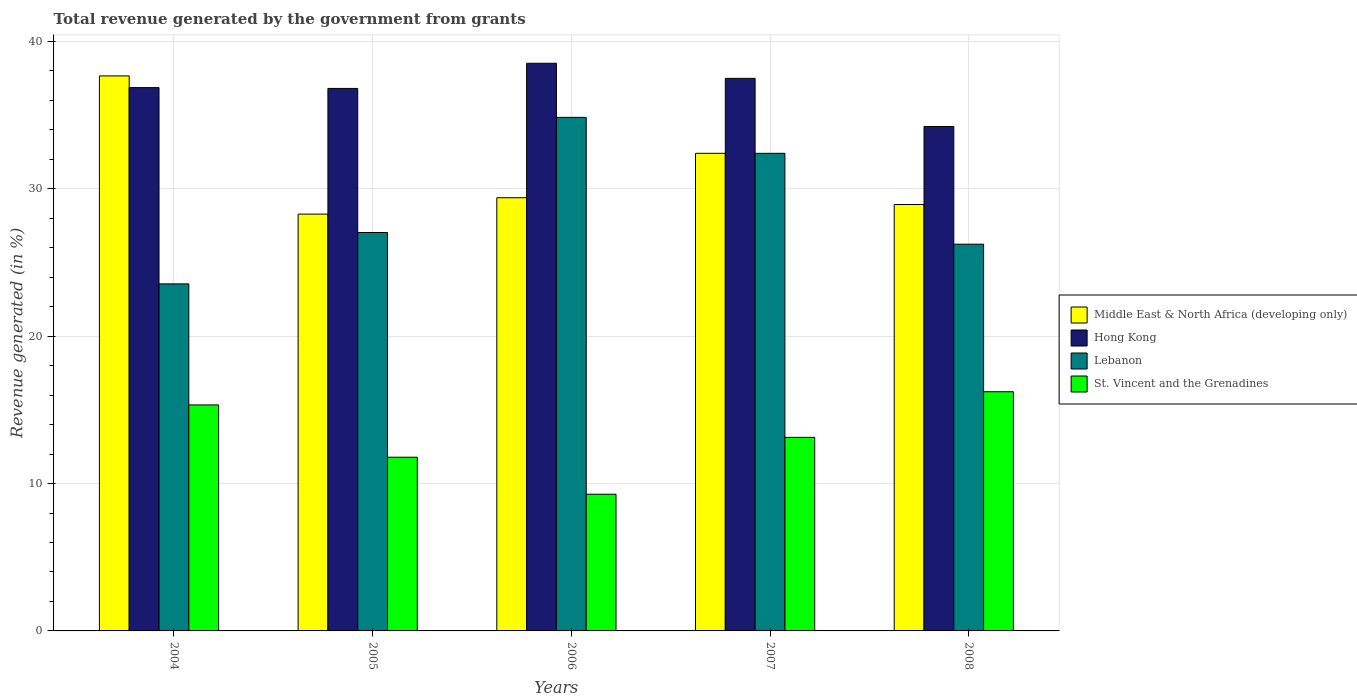Are the number of bars on each tick of the X-axis equal?
Provide a succinct answer. Yes. In how many cases, is the number of bars for a given year not equal to the number of legend labels?
Provide a short and direct response. 0. What is the total revenue generated in Middle East & North Africa (developing only) in 2006?
Keep it short and to the point. 29.4. Across all years, what is the maximum total revenue generated in Lebanon?
Ensure brevity in your answer.  34.85. Across all years, what is the minimum total revenue generated in Middle East & North Africa (developing only)?
Your answer should be compact. 28.29. In which year was the total revenue generated in St. Vincent and the Grenadines maximum?
Offer a terse response. 2008. What is the total total revenue generated in Middle East & North Africa (developing only) in the graph?
Offer a very short reply. 156.7. What is the difference between the total revenue generated in Hong Kong in 2004 and that in 2006?
Your response must be concise. -1.65. What is the difference between the total revenue generated in Hong Kong in 2005 and the total revenue generated in St. Vincent and the Grenadines in 2006?
Your answer should be compact. 27.54. What is the average total revenue generated in St. Vincent and the Grenadines per year?
Your answer should be very brief. 13.15. In the year 2004, what is the difference between the total revenue generated in St. Vincent and the Grenadines and total revenue generated in Lebanon?
Offer a terse response. -8.21. In how many years, is the total revenue generated in Hong Kong greater than 14 %?
Keep it short and to the point. 5. What is the ratio of the total revenue generated in Middle East & North Africa (developing only) in 2004 to that in 2006?
Keep it short and to the point. 1.28. Is the difference between the total revenue generated in St. Vincent and the Grenadines in 2006 and 2008 greater than the difference between the total revenue generated in Lebanon in 2006 and 2008?
Make the answer very short. No. What is the difference between the highest and the second highest total revenue generated in Middle East & North Africa (developing only)?
Your response must be concise. 5.25. What is the difference between the highest and the lowest total revenue generated in Middle East & North Africa (developing only)?
Ensure brevity in your answer.  9.38. In how many years, is the total revenue generated in Middle East & North Africa (developing only) greater than the average total revenue generated in Middle East & North Africa (developing only) taken over all years?
Give a very brief answer. 2. Is the sum of the total revenue generated in Hong Kong in 2004 and 2007 greater than the maximum total revenue generated in Middle East & North Africa (developing only) across all years?
Your answer should be very brief. Yes. What does the 2nd bar from the left in 2004 represents?
Ensure brevity in your answer.  Hong Kong. What does the 3rd bar from the right in 2005 represents?
Provide a short and direct response. Hong Kong. How many bars are there?
Your answer should be compact. 20. Are all the bars in the graph horizontal?
Make the answer very short. No. What is the difference between two consecutive major ticks on the Y-axis?
Offer a terse response. 10. Does the graph contain any zero values?
Ensure brevity in your answer.  No. Does the graph contain grids?
Give a very brief answer. Yes. How many legend labels are there?
Give a very brief answer. 4. How are the legend labels stacked?
Provide a succinct answer. Vertical. What is the title of the graph?
Ensure brevity in your answer.  Total revenue generated by the government from grants. Does "Greenland" appear as one of the legend labels in the graph?
Make the answer very short. No. What is the label or title of the Y-axis?
Make the answer very short. Revenue generated (in %). What is the Revenue generated (in %) of Middle East & North Africa (developing only) in 2004?
Keep it short and to the point. 37.67. What is the Revenue generated (in %) in Hong Kong in 2004?
Provide a short and direct response. 36.87. What is the Revenue generated (in %) in Lebanon in 2004?
Give a very brief answer. 23.55. What is the Revenue generated (in %) of St. Vincent and the Grenadines in 2004?
Provide a short and direct response. 15.34. What is the Revenue generated (in %) in Middle East & North Africa (developing only) in 2005?
Provide a short and direct response. 28.29. What is the Revenue generated (in %) of Hong Kong in 2005?
Make the answer very short. 36.82. What is the Revenue generated (in %) of Lebanon in 2005?
Provide a succinct answer. 27.04. What is the Revenue generated (in %) of St. Vincent and the Grenadines in 2005?
Provide a succinct answer. 11.79. What is the Revenue generated (in %) in Middle East & North Africa (developing only) in 2006?
Provide a succinct answer. 29.4. What is the Revenue generated (in %) in Hong Kong in 2006?
Your answer should be compact. 38.52. What is the Revenue generated (in %) in Lebanon in 2006?
Make the answer very short. 34.85. What is the Revenue generated (in %) in St. Vincent and the Grenadines in 2006?
Your response must be concise. 9.28. What is the Revenue generated (in %) of Middle East & North Africa (developing only) in 2007?
Offer a terse response. 32.41. What is the Revenue generated (in %) in Hong Kong in 2007?
Your answer should be compact. 37.5. What is the Revenue generated (in %) in Lebanon in 2007?
Provide a short and direct response. 32.41. What is the Revenue generated (in %) of St. Vincent and the Grenadines in 2007?
Provide a short and direct response. 13.14. What is the Revenue generated (in %) of Middle East & North Africa (developing only) in 2008?
Ensure brevity in your answer.  28.94. What is the Revenue generated (in %) of Hong Kong in 2008?
Make the answer very short. 34.23. What is the Revenue generated (in %) of Lebanon in 2008?
Provide a succinct answer. 26.24. What is the Revenue generated (in %) of St. Vincent and the Grenadines in 2008?
Give a very brief answer. 16.23. Across all years, what is the maximum Revenue generated (in %) in Middle East & North Africa (developing only)?
Provide a succinct answer. 37.67. Across all years, what is the maximum Revenue generated (in %) in Hong Kong?
Make the answer very short. 38.52. Across all years, what is the maximum Revenue generated (in %) in Lebanon?
Ensure brevity in your answer.  34.85. Across all years, what is the maximum Revenue generated (in %) in St. Vincent and the Grenadines?
Provide a succinct answer. 16.23. Across all years, what is the minimum Revenue generated (in %) of Middle East & North Africa (developing only)?
Provide a short and direct response. 28.29. Across all years, what is the minimum Revenue generated (in %) in Hong Kong?
Keep it short and to the point. 34.23. Across all years, what is the minimum Revenue generated (in %) in Lebanon?
Offer a terse response. 23.55. Across all years, what is the minimum Revenue generated (in %) in St. Vincent and the Grenadines?
Your response must be concise. 9.28. What is the total Revenue generated (in %) of Middle East & North Africa (developing only) in the graph?
Provide a short and direct response. 156.7. What is the total Revenue generated (in %) in Hong Kong in the graph?
Offer a terse response. 183.95. What is the total Revenue generated (in %) in Lebanon in the graph?
Offer a very short reply. 144.1. What is the total Revenue generated (in %) in St. Vincent and the Grenadines in the graph?
Ensure brevity in your answer.  65.77. What is the difference between the Revenue generated (in %) of Middle East & North Africa (developing only) in 2004 and that in 2005?
Provide a succinct answer. 9.38. What is the difference between the Revenue generated (in %) of Hong Kong in 2004 and that in 2005?
Your response must be concise. 0.06. What is the difference between the Revenue generated (in %) of Lebanon in 2004 and that in 2005?
Keep it short and to the point. -3.49. What is the difference between the Revenue generated (in %) in St. Vincent and the Grenadines in 2004 and that in 2005?
Give a very brief answer. 3.55. What is the difference between the Revenue generated (in %) of Middle East & North Africa (developing only) in 2004 and that in 2006?
Provide a short and direct response. 8.27. What is the difference between the Revenue generated (in %) in Hong Kong in 2004 and that in 2006?
Provide a short and direct response. -1.65. What is the difference between the Revenue generated (in %) in Lebanon in 2004 and that in 2006?
Offer a very short reply. -11.3. What is the difference between the Revenue generated (in %) of St. Vincent and the Grenadines in 2004 and that in 2006?
Offer a very short reply. 6.06. What is the difference between the Revenue generated (in %) of Middle East & North Africa (developing only) in 2004 and that in 2007?
Your answer should be compact. 5.25. What is the difference between the Revenue generated (in %) in Hong Kong in 2004 and that in 2007?
Your answer should be compact. -0.63. What is the difference between the Revenue generated (in %) in Lebanon in 2004 and that in 2007?
Offer a terse response. -8.86. What is the difference between the Revenue generated (in %) of St. Vincent and the Grenadines in 2004 and that in 2007?
Your answer should be compact. 2.2. What is the difference between the Revenue generated (in %) in Middle East & North Africa (developing only) in 2004 and that in 2008?
Provide a succinct answer. 8.73. What is the difference between the Revenue generated (in %) in Hong Kong in 2004 and that in 2008?
Your answer should be very brief. 2.64. What is the difference between the Revenue generated (in %) of Lebanon in 2004 and that in 2008?
Make the answer very short. -2.69. What is the difference between the Revenue generated (in %) in St. Vincent and the Grenadines in 2004 and that in 2008?
Give a very brief answer. -0.9. What is the difference between the Revenue generated (in %) of Middle East & North Africa (developing only) in 2005 and that in 2006?
Offer a terse response. -1.11. What is the difference between the Revenue generated (in %) in Hong Kong in 2005 and that in 2006?
Give a very brief answer. -1.71. What is the difference between the Revenue generated (in %) of Lebanon in 2005 and that in 2006?
Your response must be concise. -7.81. What is the difference between the Revenue generated (in %) in St. Vincent and the Grenadines in 2005 and that in 2006?
Keep it short and to the point. 2.51. What is the difference between the Revenue generated (in %) in Middle East & North Africa (developing only) in 2005 and that in 2007?
Offer a very short reply. -4.13. What is the difference between the Revenue generated (in %) of Hong Kong in 2005 and that in 2007?
Provide a short and direct response. -0.68. What is the difference between the Revenue generated (in %) in Lebanon in 2005 and that in 2007?
Keep it short and to the point. -5.37. What is the difference between the Revenue generated (in %) in St. Vincent and the Grenadines in 2005 and that in 2007?
Provide a short and direct response. -1.35. What is the difference between the Revenue generated (in %) in Middle East & North Africa (developing only) in 2005 and that in 2008?
Your response must be concise. -0.65. What is the difference between the Revenue generated (in %) in Hong Kong in 2005 and that in 2008?
Give a very brief answer. 2.58. What is the difference between the Revenue generated (in %) in Lebanon in 2005 and that in 2008?
Your answer should be compact. 0.79. What is the difference between the Revenue generated (in %) of St. Vincent and the Grenadines in 2005 and that in 2008?
Your response must be concise. -4.44. What is the difference between the Revenue generated (in %) of Middle East & North Africa (developing only) in 2006 and that in 2007?
Offer a terse response. -3.01. What is the difference between the Revenue generated (in %) of Hong Kong in 2006 and that in 2007?
Provide a succinct answer. 1.03. What is the difference between the Revenue generated (in %) of Lebanon in 2006 and that in 2007?
Keep it short and to the point. 2.44. What is the difference between the Revenue generated (in %) in St. Vincent and the Grenadines in 2006 and that in 2007?
Offer a very short reply. -3.86. What is the difference between the Revenue generated (in %) of Middle East & North Africa (developing only) in 2006 and that in 2008?
Keep it short and to the point. 0.46. What is the difference between the Revenue generated (in %) in Hong Kong in 2006 and that in 2008?
Provide a short and direct response. 4.29. What is the difference between the Revenue generated (in %) in Lebanon in 2006 and that in 2008?
Offer a very short reply. 8.61. What is the difference between the Revenue generated (in %) of St. Vincent and the Grenadines in 2006 and that in 2008?
Keep it short and to the point. -6.96. What is the difference between the Revenue generated (in %) in Middle East & North Africa (developing only) in 2007 and that in 2008?
Offer a very short reply. 3.47. What is the difference between the Revenue generated (in %) of Hong Kong in 2007 and that in 2008?
Provide a succinct answer. 3.27. What is the difference between the Revenue generated (in %) in Lebanon in 2007 and that in 2008?
Your response must be concise. 6.17. What is the difference between the Revenue generated (in %) of St. Vincent and the Grenadines in 2007 and that in 2008?
Provide a succinct answer. -3.1. What is the difference between the Revenue generated (in %) of Middle East & North Africa (developing only) in 2004 and the Revenue generated (in %) of Hong Kong in 2005?
Your answer should be very brief. 0.85. What is the difference between the Revenue generated (in %) in Middle East & North Africa (developing only) in 2004 and the Revenue generated (in %) in Lebanon in 2005?
Give a very brief answer. 10.63. What is the difference between the Revenue generated (in %) of Middle East & North Africa (developing only) in 2004 and the Revenue generated (in %) of St. Vincent and the Grenadines in 2005?
Make the answer very short. 25.88. What is the difference between the Revenue generated (in %) of Hong Kong in 2004 and the Revenue generated (in %) of Lebanon in 2005?
Keep it short and to the point. 9.83. What is the difference between the Revenue generated (in %) in Hong Kong in 2004 and the Revenue generated (in %) in St. Vincent and the Grenadines in 2005?
Keep it short and to the point. 25.08. What is the difference between the Revenue generated (in %) of Lebanon in 2004 and the Revenue generated (in %) of St. Vincent and the Grenadines in 2005?
Provide a short and direct response. 11.76. What is the difference between the Revenue generated (in %) in Middle East & North Africa (developing only) in 2004 and the Revenue generated (in %) in Hong Kong in 2006?
Keep it short and to the point. -0.86. What is the difference between the Revenue generated (in %) of Middle East & North Africa (developing only) in 2004 and the Revenue generated (in %) of Lebanon in 2006?
Provide a short and direct response. 2.81. What is the difference between the Revenue generated (in %) in Middle East & North Africa (developing only) in 2004 and the Revenue generated (in %) in St. Vincent and the Grenadines in 2006?
Provide a succinct answer. 28.39. What is the difference between the Revenue generated (in %) in Hong Kong in 2004 and the Revenue generated (in %) in Lebanon in 2006?
Your answer should be very brief. 2.02. What is the difference between the Revenue generated (in %) in Hong Kong in 2004 and the Revenue generated (in %) in St. Vincent and the Grenadines in 2006?
Provide a short and direct response. 27.6. What is the difference between the Revenue generated (in %) in Lebanon in 2004 and the Revenue generated (in %) in St. Vincent and the Grenadines in 2006?
Keep it short and to the point. 14.27. What is the difference between the Revenue generated (in %) of Middle East & North Africa (developing only) in 2004 and the Revenue generated (in %) of Hong Kong in 2007?
Give a very brief answer. 0.17. What is the difference between the Revenue generated (in %) in Middle East & North Africa (developing only) in 2004 and the Revenue generated (in %) in Lebanon in 2007?
Your answer should be very brief. 5.25. What is the difference between the Revenue generated (in %) of Middle East & North Africa (developing only) in 2004 and the Revenue generated (in %) of St. Vincent and the Grenadines in 2007?
Keep it short and to the point. 24.53. What is the difference between the Revenue generated (in %) in Hong Kong in 2004 and the Revenue generated (in %) in Lebanon in 2007?
Provide a succinct answer. 4.46. What is the difference between the Revenue generated (in %) of Hong Kong in 2004 and the Revenue generated (in %) of St. Vincent and the Grenadines in 2007?
Make the answer very short. 23.74. What is the difference between the Revenue generated (in %) in Lebanon in 2004 and the Revenue generated (in %) in St. Vincent and the Grenadines in 2007?
Your answer should be compact. 10.42. What is the difference between the Revenue generated (in %) of Middle East & North Africa (developing only) in 2004 and the Revenue generated (in %) of Hong Kong in 2008?
Offer a very short reply. 3.43. What is the difference between the Revenue generated (in %) in Middle East & North Africa (developing only) in 2004 and the Revenue generated (in %) in Lebanon in 2008?
Provide a short and direct response. 11.42. What is the difference between the Revenue generated (in %) of Middle East & North Africa (developing only) in 2004 and the Revenue generated (in %) of St. Vincent and the Grenadines in 2008?
Your response must be concise. 21.43. What is the difference between the Revenue generated (in %) in Hong Kong in 2004 and the Revenue generated (in %) in Lebanon in 2008?
Your response must be concise. 10.63. What is the difference between the Revenue generated (in %) in Hong Kong in 2004 and the Revenue generated (in %) in St. Vincent and the Grenadines in 2008?
Keep it short and to the point. 20.64. What is the difference between the Revenue generated (in %) in Lebanon in 2004 and the Revenue generated (in %) in St. Vincent and the Grenadines in 2008?
Ensure brevity in your answer.  7.32. What is the difference between the Revenue generated (in %) in Middle East & North Africa (developing only) in 2005 and the Revenue generated (in %) in Hong Kong in 2006?
Provide a succinct answer. -10.24. What is the difference between the Revenue generated (in %) in Middle East & North Africa (developing only) in 2005 and the Revenue generated (in %) in Lebanon in 2006?
Ensure brevity in your answer.  -6.57. What is the difference between the Revenue generated (in %) of Middle East & North Africa (developing only) in 2005 and the Revenue generated (in %) of St. Vincent and the Grenadines in 2006?
Your answer should be very brief. 19.01. What is the difference between the Revenue generated (in %) in Hong Kong in 2005 and the Revenue generated (in %) in Lebanon in 2006?
Keep it short and to the point. 1.96. What is the difference between the Revenue generated (in %) of Hong Kong in 2005 and the Revenue generated (in %) of St. Vincent and the Grenadines in 2006?
Provide a short and direct response. 27.54. What is the difference between the Revenue generated (in %) of Lebanon in 2005 and the Revenue generated (in %) of St. Vincent and the Grenadines in 2006?
Your response must be concise. 17.76. What is the difference between the Revenue generated (in %) of Middle East & North Africa (developing only) in 2005 and the Revenue generated (in %) of Hong Kong in 2007?
Your answer should be compact. -9.21. What is the difference between the Revenue generated (in %) of Middle East & North Africa (developing only) in 2005 and the Revenue generated (in %) of Lebanon in 2007?
Ensure brevity in your answer.  -4.13. What is the difference between the Revenue generated (in %) in Middle East & North Africa (developing only) in 2005 and the Revenue generated (in %) in St. Vincent and the Grenadines in 2007?
Provide a succinct answer. 15.15. What is the difference between the Revenue generated (in %) in Hong Kong in 2005 and the Revenue generated (in %) in Lebanon in 2007?
Give a very brief answer. 4.4. What is the difference between the Revenue generated (in %) of Hong Kong in 2005 and the Revenue generated (in %) of St. Vincent and the Grenadines in 2007?
Offer a terse response. 23.68. What is the difference between the Revenue generated (in %) of Lebanon in 2005 and the Revenue generated (in %) of St. Vincent and the Grenadines in 2007?
Give a very brief answer. 13.9. What is the difference between the Revenue generated (in %) of Middle East & North Africa (developing only) in 2005 and the Revenue generated (in %) of Hong Kong in 2008?
Your answer should be compact. -5.95. What is the difference between the Revenue generated (in %) of Middle East & North Africa (developing only) in 2005 and the Revenue generated (in %) of Lebanon in 2008?
Ensure brevity in your answer.  2.04. What is the difference between the Revenue generated (in %) of Middle East & North Africa (developing only) in 2005 and the Revenue generated (in %) of St. Vincent and the Grenadines in 2008?
Your answer should be compact. 12.05. What is the difference between the Revenue generated (in %) of Hong Kong in 2005 and the Revenue generated (in %) of Lebanon in 2008?
Provide a succinct answer. 10.57. What is the difference between the Revenue generated (in %) in Hong Kong in 2005 and the Revenue generated (in %) in St. Vincent and the Grenadines in 2008?
Ensure brevity in your answer.  20.58. What is the difference between the Revenue generated (in %) in Lebanon in 2005 and the Revenue generated (in %) in St. Vincent and the Grenadines in 2008?
Keep it short and to the point. 10.81. What is the difference between the Revenue generated (in %) of Middle East & North Africa (developing only) in 2006 and the Revenue generated (in %) of Hong Kong in 2007?
Keep it short and to the point. -8.1. What is the difference between the Revenue generated (in %) of Middle East & North Africa (developing only) in 2006 and the Revenue generated (in %) of Lebanon in 2007?
Offer a terse response. -3.01. What is the difference between the Revenue generated (in %) of Middle East & North Africa (developing only) in 2006 and the Revenue generated (in %) of St. Vincent and the Grenadines in 2007?
Your answer should be very brief. 16.26. What is the difference between the Revenue generated (in %) in Hong Kong in 2006 and the Revenue generated (in %) in Lebanon in 2007?
Provide a short and direct response. 6.11. What is the difference between the Revenue generated (in %) of Hong Kong in 2006 and the Revenue generated (in %) of St. Vincent and the Grenadines in 2007?
Make the answer very short. 25.39. What is the difference between the Revenue generated (in %) in Lebanon in 2006 and the Revenue generated (in %) in St. Vincent and the Grenadines in 2007?
Offer a very short reply. 21.72. What is the difference between the Revenue generated (in %) in Middle East & North Africa (developing only) in 2006 and the Revenue generated (in %) in Hong Kong in 2008?
Your answer should be very brief. -4.84. What is the difference between the Revenue generated (in %) of Middle East & North Africa (developing only) in 2006 and the Revenue generated (in %) of Lebanon in 2008?
Offer a terse response. 3.15. What is the difference between the Revenue generated (in %) of Middle East & North Africa (developing only) in 2006 and the Revenue generated (in %) of St. Vincent and the Grenadines in 2008?
Ensure brevity in your answer.  13.16. What is the difference between the Revenue generated (in %) of Hong Kong in 2006 and the Revenue generated (in %) of Lebanon in 2008?
Your answer should be very brief. 12.28. What is the difference between the Revenue generated (in %) of Hong Kong in 2006 and the Revenue generated (in %) of St. Vincent and the Grenadines in 2008?
Your answer should be compact. 22.29. What is the difference between the Revenue generated (in %) of Lebanon in 2006 and the Revenue generated (in %) of St. Vincent and the Grenadines in 2008?
Give a very brief answer. 18.62. What is the difference between the Revenue generated (in %) of Middle East & North Africa (developing only) in 2007 and the Revenue generated (in %) of Hong Kong in 2008?
Offer a very short reply. -1.82. What is the difference between the Revenue generated (in %) in Middle East & North Africa (developing only) in 2007 and the Revenue generated (in %) in Lebanon in 2008?
Keep it short and to the point. 6.17. What is the difference between the Revenue generated (in %) of Middle East & North Africa (developing only) in 2007 and the Revenue generated (in %) of St. Vincent and the Grenadines in 2008?
Make the answer very short. 16.18. What is the difference between the Revenue generated (in %) in Hong Kong in 2007 and the Revenue generated (in %) in Lebanon in 2008?
Ensure brevity in your answer.  11.25. What is the difference between the Revenue generated (in %) of Hong Kong in 2007 and the Revenue generated (in %) of St. Vincent and the Grenadines in 2008?
Keep it short and to the point. 21.27. What is the difference between the Revenue generated (in %) of Lebanon in 2007 and the Revenue generated (in %) of St. Vincent and the Grenadines in 2008?
Make the answer very short. 16.18. What is the average Revenue generated (in %) of Middle East & North Africa (developing only) per year?
Offer a terse response. 31.34. What is the average Revenue generated (in %) of Hong Kong per year?
Give a very brief answer. 36.79. What is the average Revenue generated (in %) in Lebanon per year?
Your answer should be very brief. 28.82. What is the average Revenue generated (in %) of St. Vincent and the Grenadines per year?
Your answer should be very brief. 13.15. In the year 2004, what is the difference between the Revenue generated (in %) in Middle East & North Africa (developing only) and Revenue generated (in %) in Hong Kong?
Offer a very short reply. 0.79. In the year 2004, what is the difference between the Revenue generated (in %) in Middle East & North Africa (developing only) and Revenue generated (in %) in Lebanon?
Make the answer very short. 14.11. In the year 2004, what is the difference between the Revenue generated (in %) of Middle East & North Africa (developing only) and Revenue generated (in %) of St. Vincent and the Grenadines?
Keep it short and to the point. 22.33. In the year 2004, what is the difference between the Revenue generated (in %) in Hong Kong and Revenue generated (in %) in Lebanon?
Make the answer very short. 13.32. In the year 2004, what is the difference between the Revenue generated (in %) of Hong Kong and Revenue generated (in %) of St. Vincent and the Grenadines?
Your answer should be compact. 21.54. In the year 2004, what is the difference between the Revenue generated (in %) of Lebanon and Revenue generated (in %) of St. Vincent and the Grenadines?
Give a very brief answer. 8.21. In the year 2005, what is the difference between the Revenue generated (in %) of Middle East & North Africa (developing only) and Revenue generated (in %) of Hong Kong?
Give a very brief answer. -8.53. In the year 2005, what is the difference between the Revenue generated (in %) in Middle East & North Africa (developing only) and Revenue generated (in %) in Lebanon?
Offer a terse response. 1.25. In the year 2005, what is the difference between the Revenue generated (in %) of Middle East & North Africa (developing only) and Revenue generated (in %) of St. Vincent and the Grenadines?
Your answer should be compact. 16.5. In the year 2005, what is the difference between the Revenue generated (in %) in Hong Kong and Revenue generated (in %) in Lebanon?
Give a very brief answer. 9.78. In the year 2005, what is the difference between the Revenue generated (in %) of Hong Kong and Revenue generated (in %) of St. Vincent and the Grenadines?
Ensure brevity in your answer.  25.03. In the year 2005, what is the difference between the Revenue generated (in %) in Lebanon and Revenue generated (in %) in St. Vincent and the Grenadines?
Your answer should be compact. 15.25. In the year 2006, what is the difference between the Revenue generated (in %) in Middle East & North Africa (developing only) and Revenue generated (in %) in Hong Kong?
Your response must be concise. -9.13. In the year 2006, what is the difference between the Revenue generated (in %) of Middle East & North Africa (developing only) and Revenue generated (in %) of Lebanon?
Keep it short and to the point. -5.45. In the year 2006, what is the difference between the Revenue generated (in %) of Middle East & North Africa (developing only) and Revenue generated (in %) of St. Vincent and the Grenadines?
Make the answer very short. 20.12. In the year 2006, what is the difference between the Revenue generated (in %) of Hong Kong and Revenue generated (in %) of Lebanon?
Your response must be concise. 3.67. In the year 2006, what is the difference between the Revenue generated (in %) in Hong Kong and Revenue generated (in %) in St. Vincent and the Grenadines?
Your answer should be very brief. 29.25. In the year 2006, what is the difference between the Revenue generated (in %) in Lebanon and Revenue generated (in %) in St. Vincent and the Grenadines?
Offer a terse response. 25.58. In the year 2007, what is the difference between the Revenue generated (in %) in Middle East & North Africa (developing only) and Revenue generated (in %) in Hong Kong?
Give a very brief answer. -5.09. In the year 2007, what is the difference between the Revenue generated (in %) of Middle East & North Africa (developing only) and Revenue generated (in %) of St. Vincent and the Grenadines?
Provide a short and direct response. 19.28. In the year 2007, what is the difference between the Revenue generated (in %) of Hong Kong and Revenue generated (in %) of Lebanon?
Ensure brevity in your answer.  5.09. In the year 2007, what is the difference between the Revenue generated (in %) in Hong Kong and Revenue generated (in %) in St. Vincent and the Grenadines?
Give a very brief answer. 24.36. In the year 2007, what is the difference between the Revenue generated (in %) in Lebanon and Revenue generated (in %) in St. Vincent and the Grenadines?
Keep it short and to the point. 19.28. In the year 2008, what is the difference between the Revenue generated (in %) in Middle East & North Africa (developing only) and Revenue generated (in %) in Hong Kong?
Give a very brief answer. -5.3. In the year 2008, what is the difference between the Revenue generated (in %) of Middle East & North Africa (developing only) and Revenue generated (in %) of Lebanon?
Provide a succinct answer. 2.69. In the year 2008, what is the difference between the Revenue generated (in %) in Middle East & North Africa (developing only) and Revenue generated (in %) in St. Vincent and the Grenadines?
Offer a terse response. 12.7. In the year 2008, what is the difference between the Revenue generated (in %) in Hong Kong and Revenue generated (in %) in Lebanon?
Your answer should be very brief. 7.99. In the year 2008, what is the difference between the Revenue generated (in %) in Hong Kong and Revenue generated (in %) in St. Vincent and the Grenadines?
Provide a succinct answer. 18. In the year 2008, what is the difference between the Revenue generated (in %) in Lebanon and Revenue generated (in %) in St. Vincent and the Grenadines?
Provide a succinct answer. 10.01. What is the ratio of the Revenue generated (in %) in Middle East & North Africa (developing only) in 2004 to that in 2005?
Ensure brevity in your answer.  1.33. What is the ratio of the Revenue generated (in %) of Hong Kong in 2004 to that in 2005?
Your answer should be compact. 1. What is the ratio of the Revenue generated (in %) of Lebanon in 2004 to that in 2005?
Ensure brevity in your answer.  0.87. What is the ratio of the Revenue generated (in %) in St. Vincent and the Grenadines in 2004 to that in 2005?
Provide a short and direct response. 1.3. What is the ratio of the Revenue generated (in %) in Middle East & North Africa (developing only) in 2004 to that in 2006?
Keep it short and to the point. 1.28. What is the ratio of the Revenue generated (in %) in Hong Kong in 2004 to that in 2006?
Ensure brevity in your answer.  0.96. What is the ratio of the Revenue generated (in %) of Lebanon in 2004 to that in 2006?
Provide a succinct answer. 0.68. What is the ratio of the Revenue generated (in %) of St. Vincent and the Grenadines in 2004 to that in 2006?
Ensure brevity in your answer.  1.65. What is the ratio of the Revenue generated (in %) of Middle East & North Africa (developing only) in 2004 to that in 2007?
Your response must be concise. 1.16. What is the ratio of the Revenue generated (in %) of Hong Kong in 2004 to that in 2007?
Offer a very short reply. 0.98. What is the ratio of the Revenue generated (in %) in Lebanon in 2004 to that in 2007?
Ensure brevity in your answer.  0.73. What is the ratio of the Revenue generated (in %) in St. Vincent and the Grenadines in 2004 to that in 2007?
Keep it short and to the point. 1.17. What is the ratio of the Revenue generated (in %) of Middle East & North Africa (developing only) in 2004 to that in 2008?
Offer a terse response. 1.3. What is the ratio of the Revenue generated (in %) of Hong Kong in 2004 to that in 2008?
Make the answer very short. 1.08. What is the ratio of the Revenue generated (in %) in Lebanon in 2004 to that in 2008?
Ensure brevity in your answer.  0.9. What is the ratio of the Revenue generated (in %) in St. Vincent and the Grenadines in 2004 to that in 2008?
Offer a terse response. 0.94. What is the ratio of the Revenue generated (in %) of Middle East & North Africa (developing only) in 2005 to that in 2006?
Your answer should be very brief. 0.96. What is the ratio of the Revenue generated (in %) of Hong Kong in 2005 to that in 2006?
Provide a short and direct response. 0.96. What is the ratio of the Revenue generated (in %) in Lebanon in 2005 to that in 2006?
Make the answer very short. 0.78. What is the ratio of the Revenue generated (in %) in St. Vincent and the Grenadines in 2005 to that in 2006?
Provide a short and direct response. 1.27. What is the ratio of the Revenue generated (in %) in Middle East & North Africa (developing only) in 2005 to that in 2007?
Ensure brevity in your answer.  0.87. What is the ratio of the Revenue generated (in %) in Hong Kong in 2005 to that in 2007?
Keep it short and to the point. 0.98. What is the ratio of the Revenue generated (in %) in Lebanon in 2005 to that in 2007?
Offer a very short reply. 0.83. What is the ratio of the Revenue generated (in %) in St. Vincent and the Grenadines in 2005 to that in 2007?
Keep it short and to the point. 0.9. What is the ratio of the Revenue generated (in %) in Middle East & North Africa (developing only) in 2005 to that in 2008?
Your answer should be compact. 0.98. What is the ratio of the Revenue generated (in %) in Hong Kong in 2005 to that in 2008?
Provide a succinct answer. 1.08. What is the ratio of the Revenue generated (in %) of Lebanon in 2005 to that in 2008?
Your response must be concise. 1.03. What is the ratio of the Revenue generated (in %) in St. Vincent and the Grenadines in 2005 to that in 2008?
Give a very brief answer. 0.73. What is the ratio of the Revenue generated (in %) in Middle East & North Africa (developing only) in 2006 to that in 2007?
Provide a short and direct response. 0.91. What is the ratio of the Revenue generated (in %) of Hong Kong in 2006 to that in 2007?
Your answer should be very brief. 1.03. What is the ratio of the Revenue generated (in %) in Lebanon in 2006 to that in 2007?
Your answer should be very brief. 1.08. What is the ratio of the Revenue generated (in %) in St. Vincent and the Grenadines in 2006 to that in 2007?
Provide a succinct answer. 0.71. What is the ratio of the Revenue generated (in %) of Middle East & North Africa (developing only) in 2006 to that in 2008?
Your answer should be compact. 1.02. What is the ratio of the Revenue generated (in %) in Hong Kong in 2006 to that in 2008?
Your response must be concise. 1.13. What is the ratio of the Revenue generated (in %) in Lebanon in 2006 to that in 2008?
Provide a succinct answer. 1.33. What is the ratio of the Revenue generated (in %) in St. Vincent and the Grenadines in 2006 to that in 2008?
Provide a short and direct response. 0.57. What is the ratio of the Revenue generated (in %) of Middle East & North Africa (developing only) in 2007 to that in 2008?
Give a very brief answer. 1.12. What is the ratio of the Revenue generated (in %) in Hong Kong in 2007 to that in 2008?
Provide a succinct answer. 1.1. What is the ratio of the Revenue generated (in %) in Lebanon in 2007 to that in 2008?
Your answer should be very brief. 1.24. What is the ratio of the Revenue generated (in %) of St. Vincent and the Grenadines in 2007 to that in 2008?
Make the answer very short. 0.81. What is the difference between the highest and the second highest Revenue generated (in %) in Middle East & North Africa (developing only)?
Your response must be concise. 5.25. What is the difference between the highest and the second highest Revenue generated (in %) of Hong Kong?
Offer a very short reply. 1.03. What is the difference between the highest and the second highest Revenue generated (in %) in Lebanon?
Your answer should be very brief. 2.44. What is the difference between the highest and the second highest Revenue generated (in %) of St. Vincent and the Grenadines?
Your answer should be very brief. 0.9. What is the difference between the highest and the lowest Revenue generated (in %) of Middle East & North Africa (developing only)?
Provide a succinct answer. 9.38. What is the difference between the highest and the lowest Revenue generated (in %) in Hong Kong?
Your answer should be compact. 4.29. What is the difference between the highest and the lowest Revenue generated (in %) in Lebanon?
Give a very brief answer. 11.3. What is the difference between the highest and the lowest Revenue generated (in %) of St. Vincent and the Grenadines?
Your answer should be very brief. 6.96. 